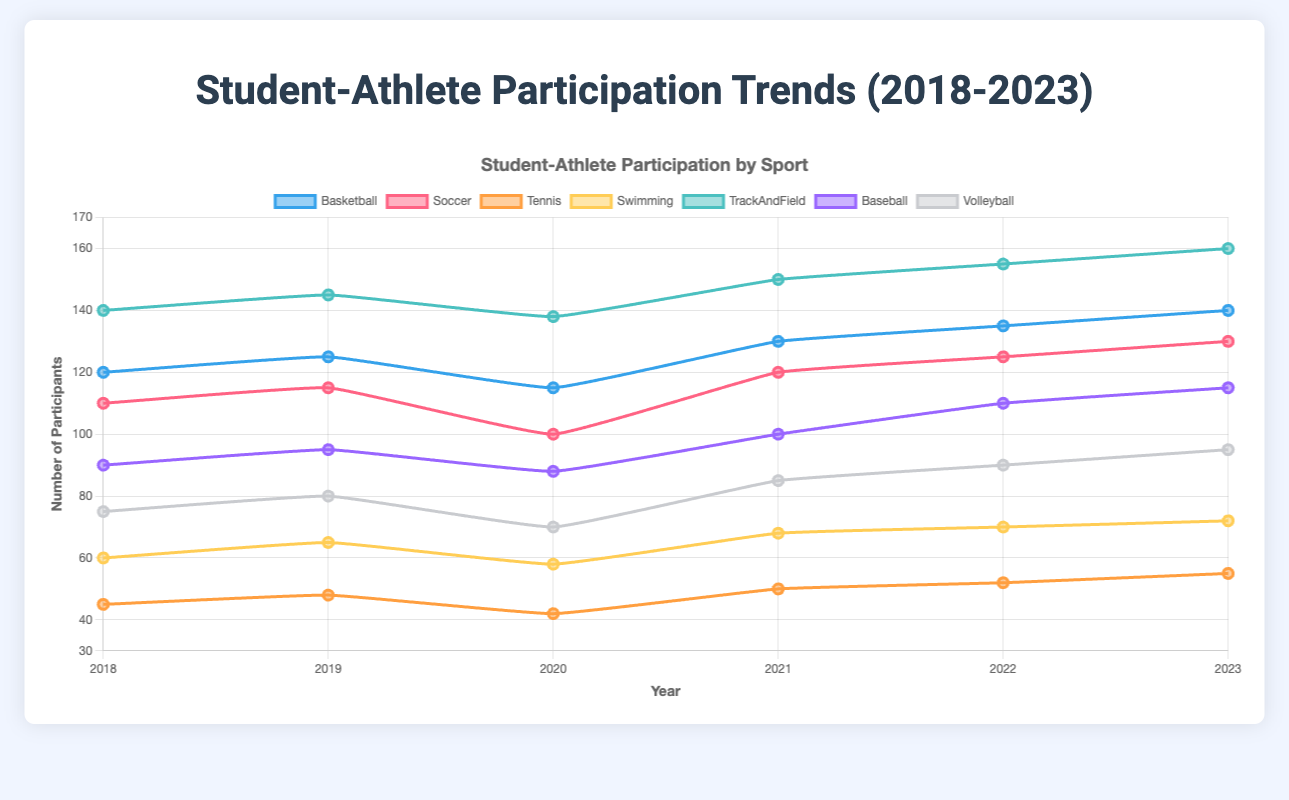What is the trend in basketball participation from 2018 to 2023? Looking at the line representing basketball, we observe the following participant numbers: 120 in 2018, 125 in 2019, 115 in 2020, 130 in 2021, 135 in 2022, and 140 in 2023. The general trend shows an overall increase in basketball participation over these years.
Answer: Increasing trend Which sport had the highest participation in 2023 and what was the number? By examining the data for 2023, we find that TrackAndField had the highest participation with 160 participants. The line for TrackAndField reaches the highest point on the graph for the year 2023.
Answer: TrackAndField, 160 Which year did baseball have the lowest number of participants and how many were there? Reviewing the line for baseball, the lowest number of participants was in 2020 with 88 participants.
Answer: 2020, 88 Did soccer show an increasing or decreasing trend from 2018 to 2023? Analyzing the data for soccer, we observe: 110 in 2018, 115 in 2019, 100 in 2020, 120 in 2021, 125 in 2022, and 130 in 2023. The trend indicates an overall increase in participation.
Answer: Increasing trend What is the total number of participants across all sports in the year 2022? Summing up the participation numbers for all sports in 2022: Basketball (135) + Soccer (125) + Tennis (52) + Swimming (70) + TrackAndField (155) + Baseball (110) + Volleyball (90) = 737
Answer: 737 Between 2019 and 2020, which sport had the greatest decline in participation and by how much? Calculating the differences, Basketball: 125-115=10, Soccer: 115-100=15, Tennis: 48-42=6, Swimming: 65-58=7, TrackAndField: 145-138=7, Baseball: 95-88=7, Volleyball: 80-70=10. Soccer had the greatest decline with a difference of 15 participants.
Answer: Soccer, 15 In which year did swimming see the highest number of participants and what was the count? By following the line for swimming, the highest number of participants was in 2023 with 72 participants.
Answer: 2023, 72 Compare the participation of Volleyball and Tennis in 2021. Which had more participants and by how much? Volleyball had 85 participants while Tennis had 50 participants in 2021. Comparing these, Volleyball had 85 - 50 = 35 more participants than Tennis.
Answer: Volleyball, by 35 Calculate the average annual participation in TrackAndField from 2018 to 2023. Adding up the TrackAndField participation for each year: (140 + 145 + 138 + 150 + 155 + 160) = 888. The average is 888 / 6 = 148
Answer: 148 